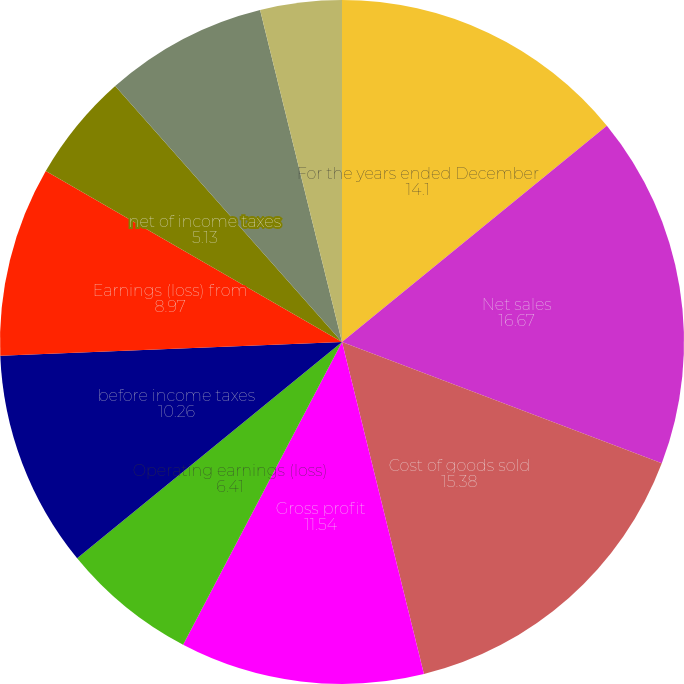<chart> <loc_0><loc_0><loc_500><loc_500><pie_chart><fcel>For the years ended December<fcel>Net sales<fcel>Cost of goods sold<fcel>Gross profit<fcel>Operating earnings (loss)<fcel>before income taxes<fcel>Earnings (loss) from<fcel>net of income taxes<fcel>Net earnings (loss)<fcel>Continuing operations<nl><fcel>14.1%<fcel>16.67%<fcel>15.38%<fcel>11.54%<fcel>6.41%<fcel>10.26%<fcel>8.97%<fcel>5.13%<fcel>7.69%<fcel>3.85%<nl></chart> 